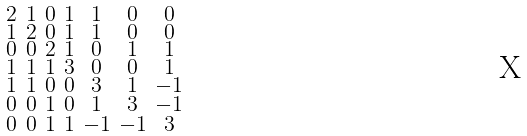<formula> <loc_0><loc_0><loc_500><loc_500>\begin{smallmatrix} 2 & 1 & 0 & 1 & 1 & 0 & 0 \\ 1 & 2 & 0 & 1 & 1 & 0 & 0 \\ 0 & 0 & 2 & 1 & 0 & 1 & 1 \\ 1 & 1 & 1 & 3 & 0 & 0 & 1 \\ 1 & 1 & 0 & 0 & 3 & 1 & - 1 \\ 0 & 0 & 1 & 0 & 1 & 3 & - 1 \\ 0 & 0 & 1 & 1 & - 1 & - 1 & 3 \end{smallmatrix}</formula> 